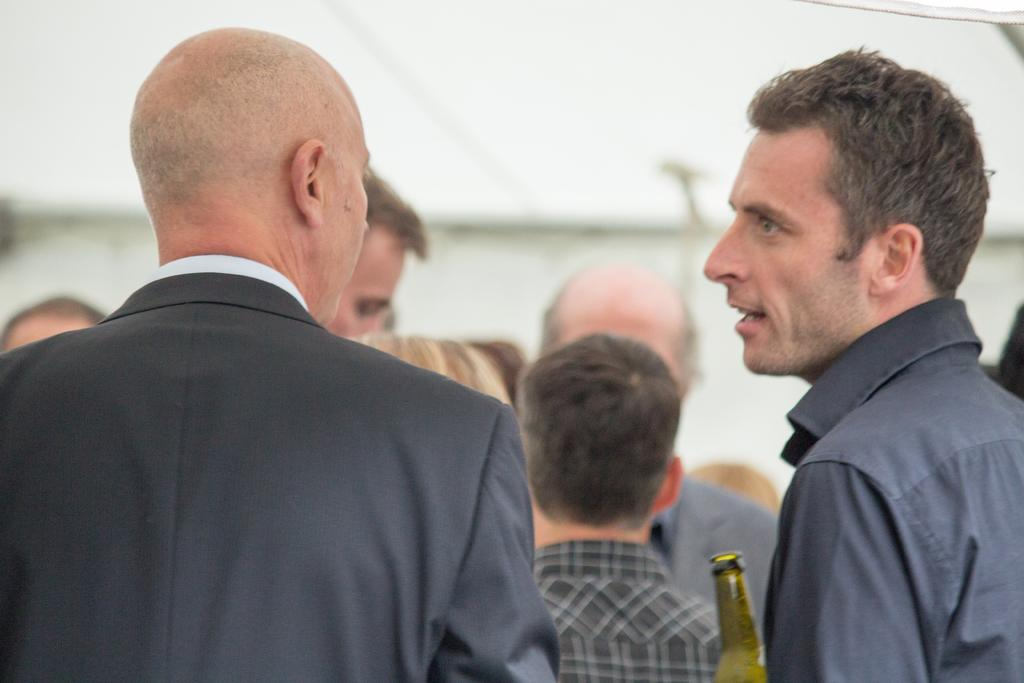How many people are present in the image? There are two people in the image. What are the two people doing in the image? The two people are looking at each other. Can you describe the background of the image? There are people and a bottle in the background of the image. What type of instrument is the person on the left playing in the image? There is no instrument present in the image; the two people are simply looking at each other. 